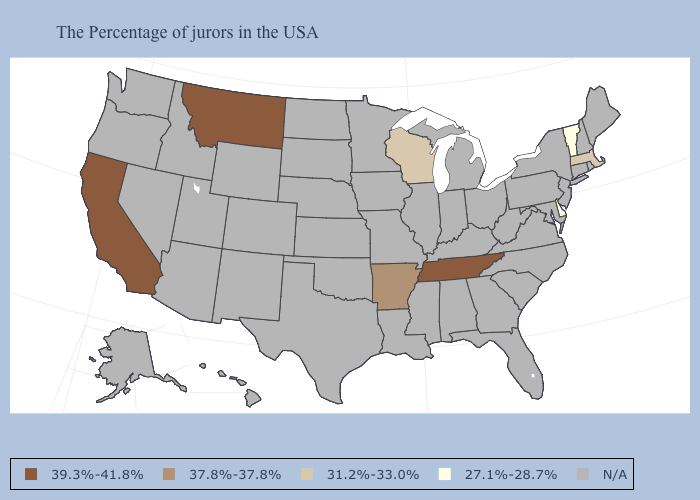Does California have the highest value in the USA?
Give a very brief answer. Yes. Does the map have missing data?
Keep it brief. Yes. Does the first symbol in the legend represent the smallest category?
Give a very brief answer. No. Is the legend a continuous bar?
Give a very brief answer. No. Does Massachusetts have the lowest value in the Northeast?
Short answer required. No. How many symbols are there in the legend?
Write a very short answer. 5. Is the legend a continuous bar?
Write a very short answer. No. What is the lowest value in states that border North Dakota?
Short answer required. 39.3%-41.8%. Name the states that have a value in the range N/A?
Be succinct. Maine, Rhode Island, New Hampshire, Connecticut, New York, New Jersey, Maryland, Pennsylvania, Virginia, North Carolina, South Carolina, West Virginia, Ohio, Florida, Georgia, Michigan, Kentucky, Indiana, Alabama, Illinois, Mississippi, Louisiana, Missouri, Minnesota, Iowa, Kansas, Nebraska, Oklahoma, Texas, South Dakota, North Dakota, Wyoming, Colorado, New Mexico, Utah, Arizona, Idaho, Nevada, Washington, Oregon, Alaska, Hawaii. What is the value of Kentucky?
Short answer required. N/A. What is the value of Wyoming?
Keep it brief. N/A. What is the highest value in states that border Alabama?
Short answer required. 39.3%-41.8%. Name the states that have a value in the range 31.2%-33.0%?
Be succinct. Massachusetts, Wisconsin. What is the value of Wisconsin?
Keep it brief. 31.2%-33.0%. Name the states that have a value in the range N/A?
Short answer required. Maine, Rhode Island, New Hampshire, Connecticut, New York, New Jersey, Maryland, Pennsylvania, Virginia, North Carolina, South Carolina, West Virginia, Ohio, Florida, Georgia, Michigan, Kentucky, Indiana, Alabama, Illinois, Mississippi, Louisiana, Missouri, Minnesota, Iowa, Kansas, Nebraska, Oklahoma, Texas, South Dakota, North Dakota, Wyoming, Colorado, New Mexico, Utah, Arizona, Idaho, Nevada, Washington, Oregon, Alaska, Hawaii. 